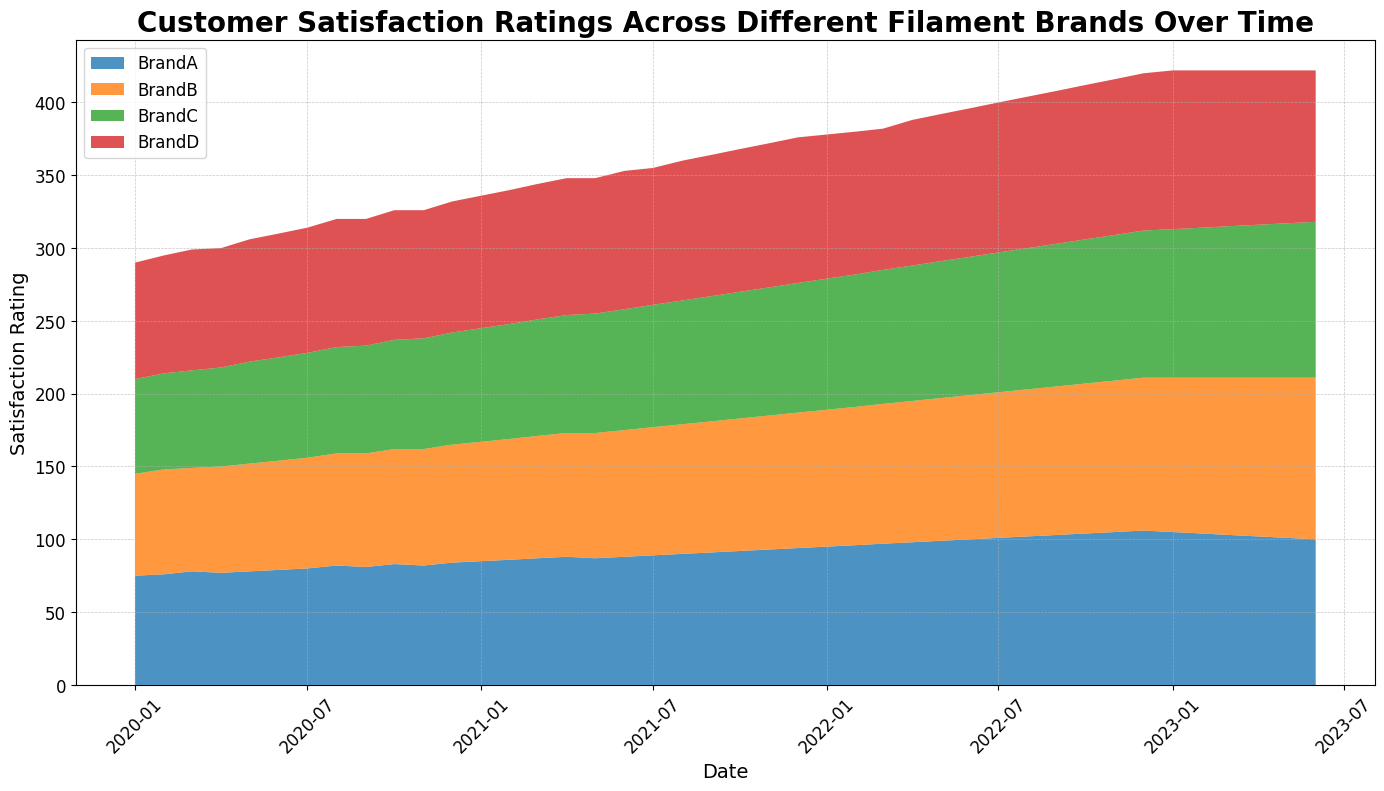what's the average customer satisfaction rating for BrandA from January 2022 to June 2022? To find the average customer satisfaction rating for BrandA from January 2022 to June 2022, we sum the ratings (95, 96, 97, 98, 99, 100) and divide by the number of ratings. The sum is 585, and there are 6 ratings. The average is 585/6.
Answer: 97.5 Which brand had the highest overall customer satisfaction rating in December 2022? From the figure, we look at the data points for December 2022 across all brands. BrandD has the highest rating of 108.
Answer: BrandD How did BrandB's customer satisfaction rating change from January 2020 to January 2023? To determine the change, we subtract BrandB's rating in January 2020 (70) from its rating in January 2023 (106). The change is 106 - 70.
Answer: 36 During which month in 2022 did BrandC’s customer satisfaction rating first reach or exceed 95? To find the first month BrandC's rating reached at least 95 in 2022, we look at the data for BrandC. March 2022 shows a rating of 95.
Answer: March 2022 Which brand shows the most noticeable upward trend in customer satisfaction ratings over the entire period? To identify the brand with the most noticeable upward trend, we observe the slopes of the area chart sections over time. BrandD's area consistently increases steeply compared to other brands.
Answer: BrandD What is the difference in customer satisfaction rating for BrandD between June 2022 and June 2023? To find the difference, we subtract the rating of BrandD in June 2022 (102) from its rating in June 2023 (104). The change is 104 - 102.
Answer: 2 Consider the total customer satisfaction ratings for all brands combined in July 2021. What is this value? We sum the ratings of all brands in July 2021: BrandA (89), BrandB (88), BrandC (84), and BrandD (94). The sum is 89 + 88 + 84 + 94.
Answer: 355 Between which two consecutive months is the largest drop in customer satisfaction for BrandA observed? Observing BrandA's ratings, the most significant drop appears between January 2023 (105) and February 2023 (104).
Answer: January 2023 and February 2023 Comparing Brands A, B, and C in December 2021, which brand has the lowest customer satisfaction rating, and what is this value? In December 2021, BrandA has a rating of 94, BrandB is 93, and BrandC is 89. BrandC has the lowest rating.
Answer: BrandC, 89 